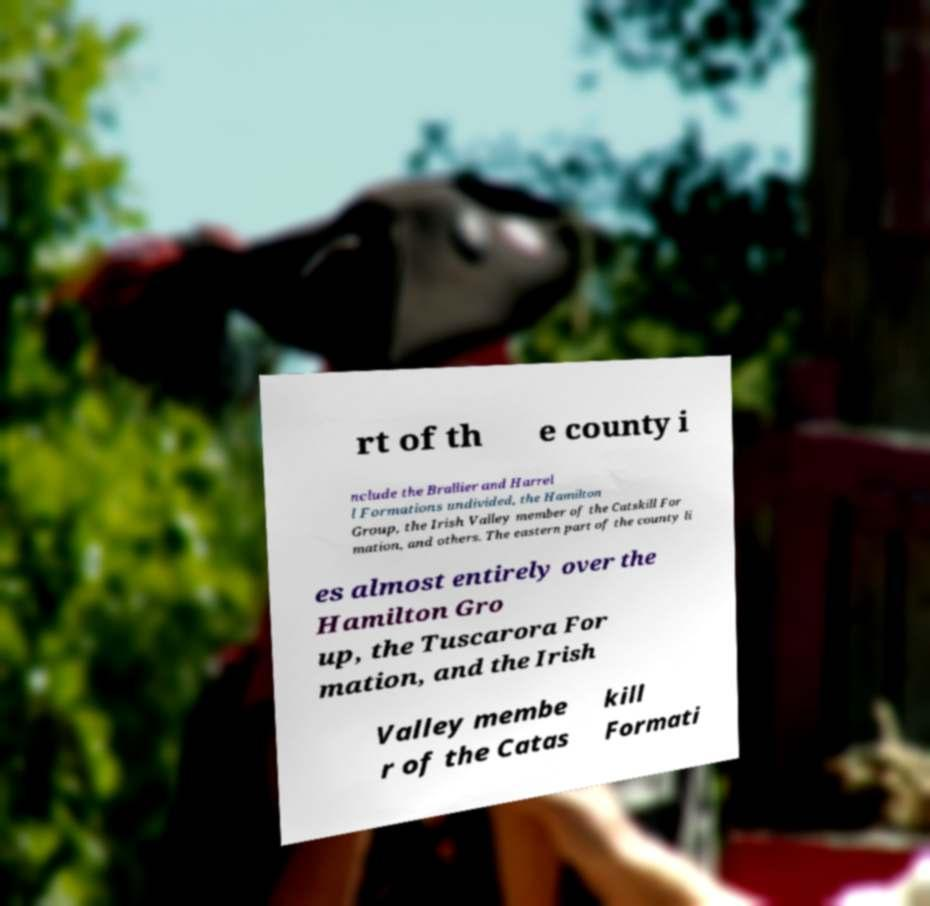For documentation purposes, I need the text within this image transcribed. Could you provide that? rt of th e county i nclude the Brallier and Harrel l Formations undivided, the Hamilton Group, the Irish Valley member of the Catskill For mation, and others. The eastern part of the county li es almost entirely over the Hamilton Gro up, the Tuscarora For mation, and the Irish Valley membe r of the Catas kill Formati 